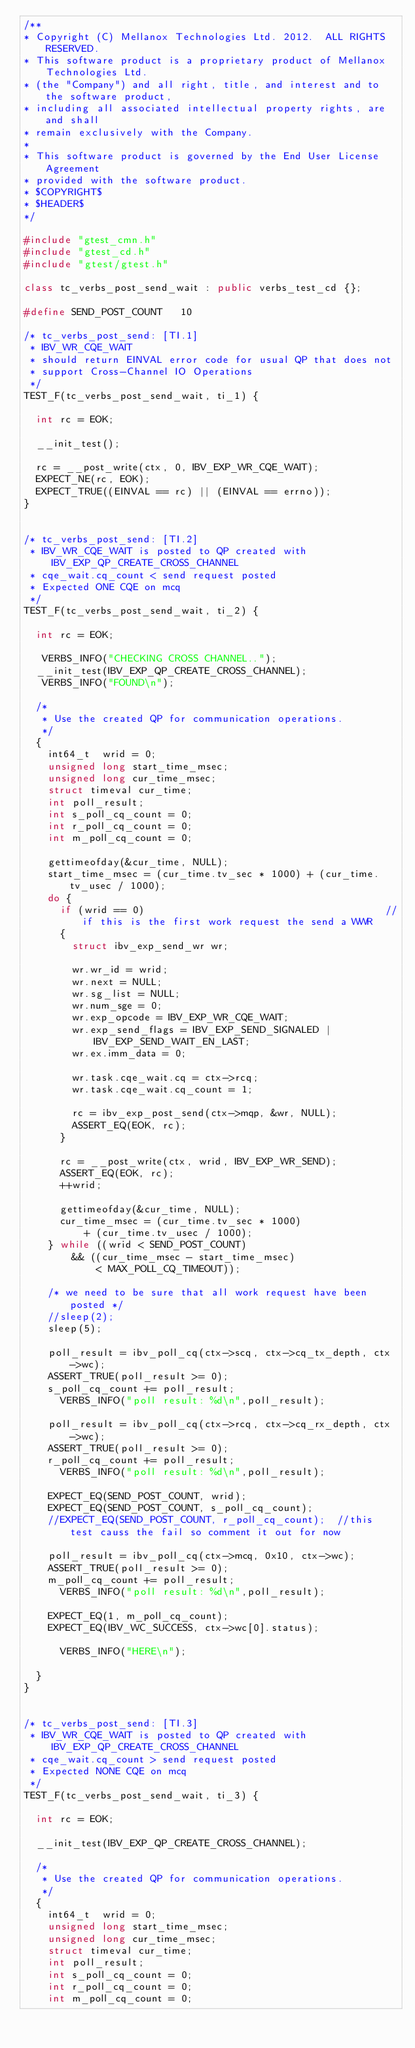Convert code to text. <code><loc_0><loc_0><loc_500><loc_500><_C++_>/**
* Copyright (C) Mellanox Technologies Ltd. 2012.  ALL RIGHTS RESERVED.
* This software product is a proprietary product of Mellanox Technologies Ltd.
* (the "Company") and all right, title, and interest and to the software product,
* including all associated intellectual property rights, are and shall
* remain exclusively with the Company.
*
* This software product is governed by the End User License Agreement
* provided with the software product.
* $COPYRIGHT$
* $HEADER$
*/

#include "gtest_cmn.h"
#include "gtest_cd.h"
#include "gtest/gtest.h"

class tc_verbs_post_send_wait : public verbs_test_cd {};

#define SEND_POST_COUNT		10  

/* tc_verbs_post_send: [TI.1]
 * IBV_WR_CQE_WAIT
 * should return EINVAL error code for usual QP that does not
 * support Cross-Channel IO Operations
 */
TEST_F(tc_verbs_post_send_wait, ti_1) {

	int rc = EOK;

	__init_test();

	rc = __post_write(ctx, 0, IBV_EXP_WR_CQE_WAIT);
	EXPECT_NE(rc, EOK);
	EXPECT_TRUE((EINVAL == rc) || (EINVAL == errno));
}


/* tc_verbs_post_send: [TI.2]
 * IBV_WR_CQE_WAIT is posted to QP created with IBV_EXP_QP_CREATE_CROSS_CHANNEL
 * cqe_wait.cq_count < send request posted
 * Expected ONE CQE on mcq
 */
TEST_F(tc_verbs_post_send_wait, ti_2) {

	int rc = EOK;

   VERBS_INFO("CHECKING CROSS CHANNEL..");
	__init_test(IBV_EXP_QP_CREATE_CROSS_CHANNEL);
   VERBS_INFO("FOUND\n");

	/*
	 * Use the created QP for communication operations.
	 */
	{
		int64_t	 wrid = 0;
		unsigned long start_time_msec;
		unsigned long cur_time_msec;
		struct timeval cur_time;
		int poll_result;
		int s_poll_cq_count = 0;
		int r_poll_cq_count = 0;
		int m_poll_cq_count = 0;

		gettimeofday(&cur_time, NULL);
		start_time_msec = (cur_time.tv_sec * 1000) + (cur_time.tv_usec / 1000);
		do {
			if (wrid == 0)                                        //if this is the first work request the send a WWR
			{
				struct ibv_exp_send_wr wr;

				wr.wr_id = wrid;
				wr.next = NULL;
				wr.sg_list = NULL;
				wr.num_sge = 0;
				wr.exp_opcode = IBV_EXP_WR_CQE_WAIT;
				wr.exp_send_flags = IBV_EXP_SEND_SIGNALED | IBV_EXP_SEND_WAIT_EN_LAST;
				wr.ex.imm_data = 0;

				wr.task.cqe_wait.cq = ctx->rcq;
				wr.task.cqe_wait.cq_count = 1;

				rc = ibv_exp_post_send(ctx->mqp, &wr, NULL);
				ASSERT_EQ(EOK, rc);
			}

			rc = __post_write(ctx, wrid, IBV_EXP_WR_SEND);
			ASSERT_EQ(EOK, rc);
			++wrid;

			gettimeofday(&cur_time, NULL);
			cur_time_msec = (cur_time.tv_sec * 1000)
					+ (cur_time.tv_usec / 1000);
		} while ((wrid < SEND_POST_COUNT)
				&& ((cur_time_msec - start_time_msec)
						< MAX_POLL_CQ_TIMEOUT));

		/* we need to be sure that all work request have been posted */
		//sleep(2);
		sleep(5);

		poll_result = ibv_poll_cq(ctx->scq, ctx->cq_tx_depth, ctx->wc);
		ASSERT_TRUE(poll_result >= 0);
		s_poll_cq_count += poll_result;
      VERBS_INFO("poll result: %d\n",poll_result);

		poll_result = ibv_poll_cq(ctx->rcq, ctx->cq_rx_depth, ctx->wc);
		ASSERT_TRUE(poll_result >= 0);
		r_poll_cq_count += poll_result;
      VERBS_INFO("poll result: %d\n",poll_result);

		EXPECT_EQ(SEND_POST_COUNT, wrid);
		EXPECT_EQ(SEND_POST_COUNT, s_poll_cq_count);
		//EXPECT_EQ(SEND_POST_COUNT, r_poll_cq_count);  //this test causs the fail so comment it out for now

		poll_result = ibv_poll_cq(ctx->mcq, 0x10, ctx->wc);
		ASSERT_TRUE(poll_result >= 0);
		m_poll_cq_count += poll_result;
      VERBS_INFO("poll result: %d\n",poll_result);

		EXPECT_EQ(1, m_poll_cq_count);
		EXPECT_EQ(IBV_WC_SUCCESS, ctx->wc[0].status);

      VERBS_INFO("HERE\n");

	}
}


/* tc_verbs_post_send: [TI.3]
 * IBV_WR_CQE_WAIT is posted to QP created with IBV_EXP_QP_CREATE_CROSS_CHANNEL
 * cqe_wait.cq_count > send request posted
 * Expected NONE CQE on mcq
 */
TEST_F(tc_verbs_post_send_wait, ti_3) {

	int rc = EOK;

	__init_test(IBV_EXP_QP_CREATE_CROSS_CHANNEL);

	/*
	 * Use the created QP for communication operations.
	 */
	{
		int64_t	 wrid = 0;
		unsigned long start_time_msec;
		unsigned long cur_time_msec;
		struct timeval cur_time;
		int poll_result;
		int s_poll_cq_count = 0;
		int r_poll_cq_count = 0;
		int m_poll_cq_count = 0;
</code> 